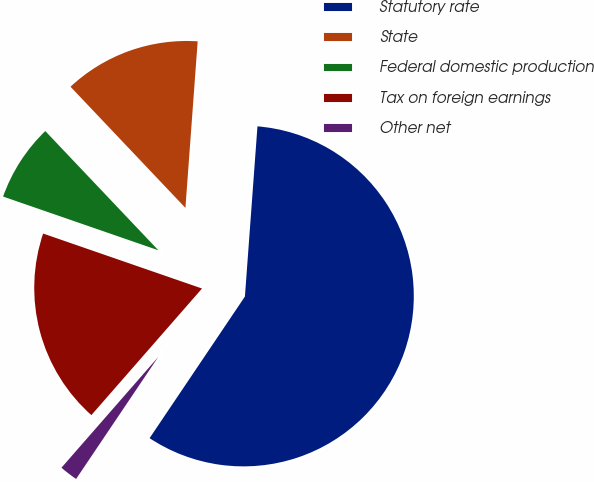Convert chart to OTSL. <chart><loc_0><loc_0><loc_500><loc_500><pie_chart><fcel>Statutory rate<fcel>State<fcel>Federal domestic production<fcel>Tax on foreign earnings<fcel>Other net<nl><fcel>58.26%<fcel>13.25%<fcel>7.62%<fcel>18.87%<fcel>2.0%<nl></chart> 